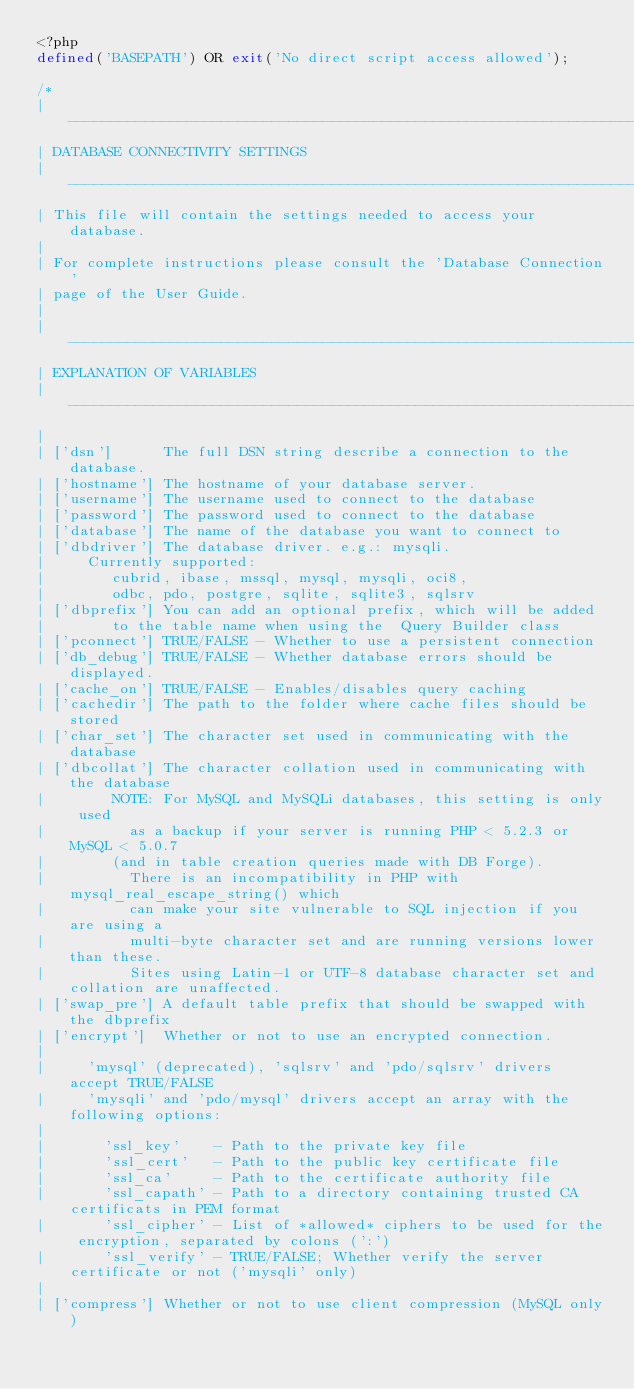Convert code to text. <code><loc_0><loc_0><loc_500><loc_500><_PHP_><?php
defined('BASEPATH') OR exit('No direct script access allowed');

/*
| -------------------------------------------------------------------
| DATABASE CONNECTIVITY SETTINGS
| -------------------------------------------------------------------
| This file will contain the settings needed to access your database.
|
| For complete instructions please consult the 'Database Connection'
| page of the User Guide.
|
| -------------------------------------------------------------------
| EXPLANATION OF VARIABLES
| -------------------------------------------------------------------
|
|	['dsn']      The full DSN string describe a connection to the database.
|	['hostname'] The hostname of your database server.
|	['username'] The username used to connect to the database
|	['password'] The password used to connect to the database
|	['database'] The name of the database you want to connect to
|	['dbdriver'] The database driver. e.g.: mysqli.
|			Currently supported:
|				 cubrid, ibase, mssql, mysql, mysqli, oci8,
|				 odbc, pdo, postgre, sqlite, sqlite3, sqlsrv
|	['dbprefix'] You can add an optional prefix, which will be added
|				 to the table name when using the  Query Builder class
|	['pconnect'] TRUE/FALSE - Whether to use a persistent connection
|	['db_debug'] TRUE/FALSE - Whether database errors should be displayed.
|	['cache_on'] TRUE/FALSE - Enables/disables query caching
|	['cachedir'] The path to the folder where cache files should be stored
|	['char_set'] The character set used in communicating with the database
|	['dbcollat'] The character collation used in communicating with the database
|				 NOTE: For MySQL and MySQLi databases, this setting is only used
| 				 as a backup if your server is running PHP < 5.2.3 or MySQL < 5.0.7
|				 (and in table creation queries made with DB Forge).
| 				 There is an incompatibility in PHP with mysql_real_escape_string() which
| 				 can make your site vulnerable to SQL injection if you are using a
| 				 multi-byte character set and are running versions lower than these.
| 				 Sites using Latin-1 or UTF-8 database character set and collation are unaffected.
|	['swap_pre'] A default table prefix that should be swapped with the dbprefix
|	['encrypt']  Whether or not to use an encrypted connection.
|
|			'mysql' (deprecated), 'sqlsrv' and 'pdo/sqlsrv' drivers accept TRUE/FALSE
|			'mysqli' and 'pdo/mysql' drivers accept an array with the following options:
|
|				'ssl_key'    - Path to the private key file
|				'ssl_cert'   - Path to the public key certificate file
|				'ssl_ca'     - Path to the certificate authority file
|				'ssl_capath' - Path to a directory containing trusted CA certificats in PEM format
|				'ssl_cipher' - List of *allowed* ciphers to be used for the encryption, separated by colons (':')
|				'ssl_verify' - TRUE/FALSE; Whether verify the server certificate or not ('mysqli' only)
|
|	['compress'] Whether or not to use client compression (MySQL only)</code> 